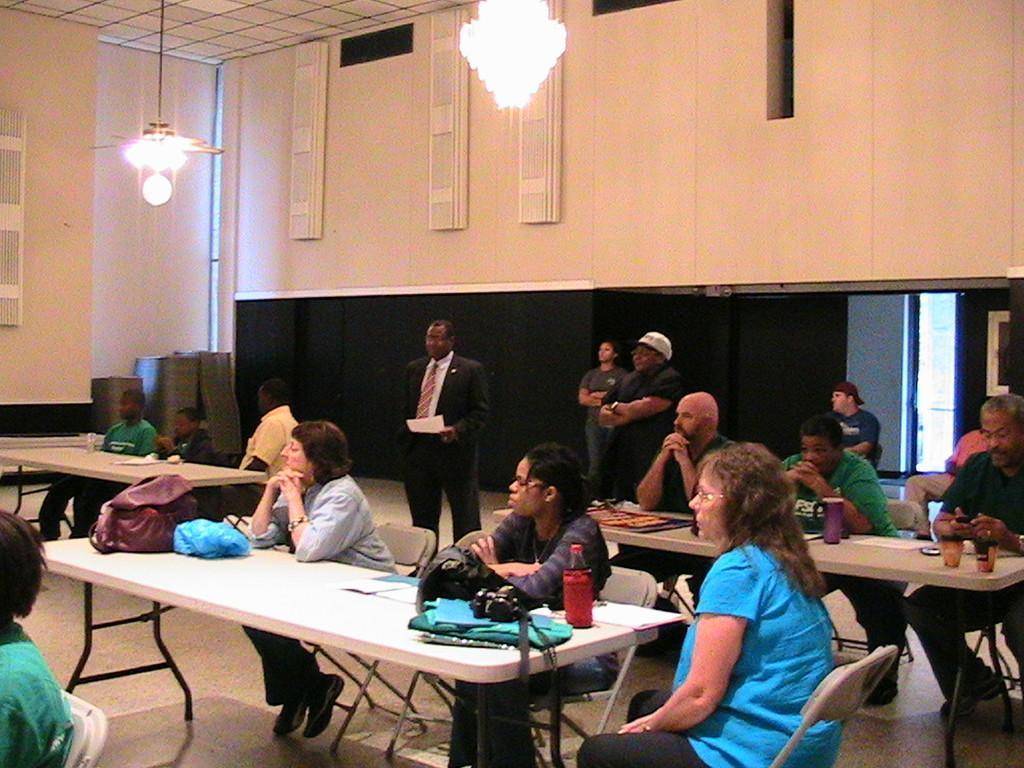Please provide a concise description of this image. In this given picture there are many people sitting in the chairs in front of their respective tables. On the table there are some bags, camera and a bottle here. Some of the people were standing. There is a chandelier to the ceiling. In the background there are some lights and a wall here. 